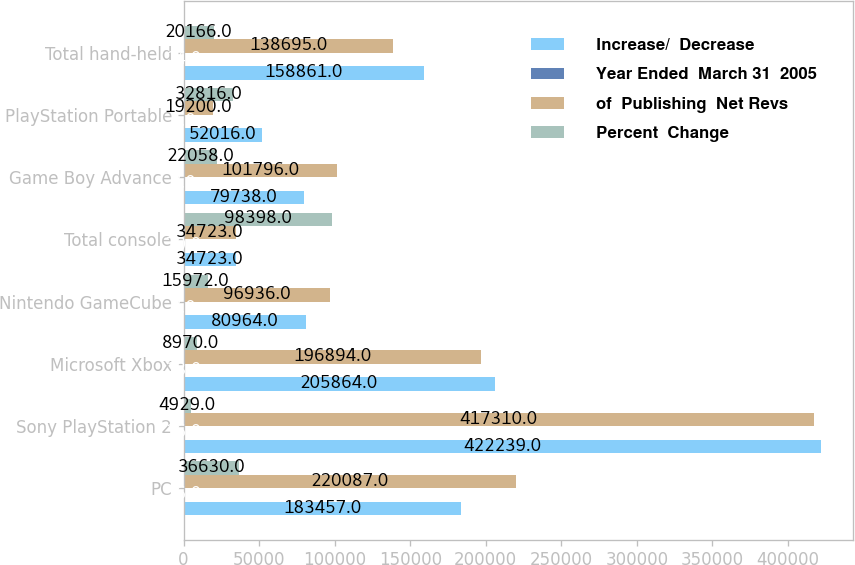<chart> <loc_0><loc_0><loc_500><loc_500><stacked_bar_chart><ecel><fcel>PC<fcel>Sony PlayStation 2<fcel>Microsoft Xbox<fcel>Nintendo GameCube<fcel>Total console<fcel>Game Boy Advance<fcel>PlayStation Portable<fcel>Total hand-held<nl><fcel>Increase/  Decrease<fcel>183457<fcel>422239<fcel>205864<fcel>80964<fcel>34723<fcel>79738<fcel>52016<fcel>158861<nl><fcel>Year Ended  March 31  2005<fcel>16<fcel>36<fcel>18<fcel>7<fcel>70<fcel>7<fcel>5<fcel>14<nl><fcel>of  Publishing  Net Revs<fcel>220087<fcel>417310<fcel>196894<fcel>96936<fcel>34723<fcel>101796<fcel>19200<fcel>138695<nl><fcel>Percent  Change<fcel>36630<fcel>4929<fcel>8970<fcel>15972<fcel>98398<fcel>22058<fcel>32816<fcel>20166<nl></chart> 